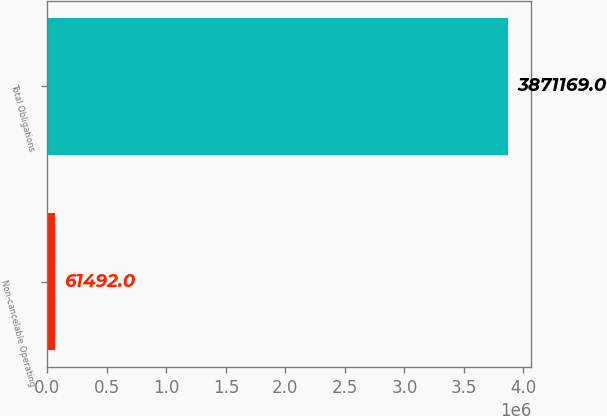Convert chart to OTSL. <chart><loc_0><loc_0><loc_500><loc_500><bar_chart><fcel>Non-cancelable Operating<fcel>Total Obligations<nl><fcel>61492<fcel>3.87117e+06<nl></chart> 